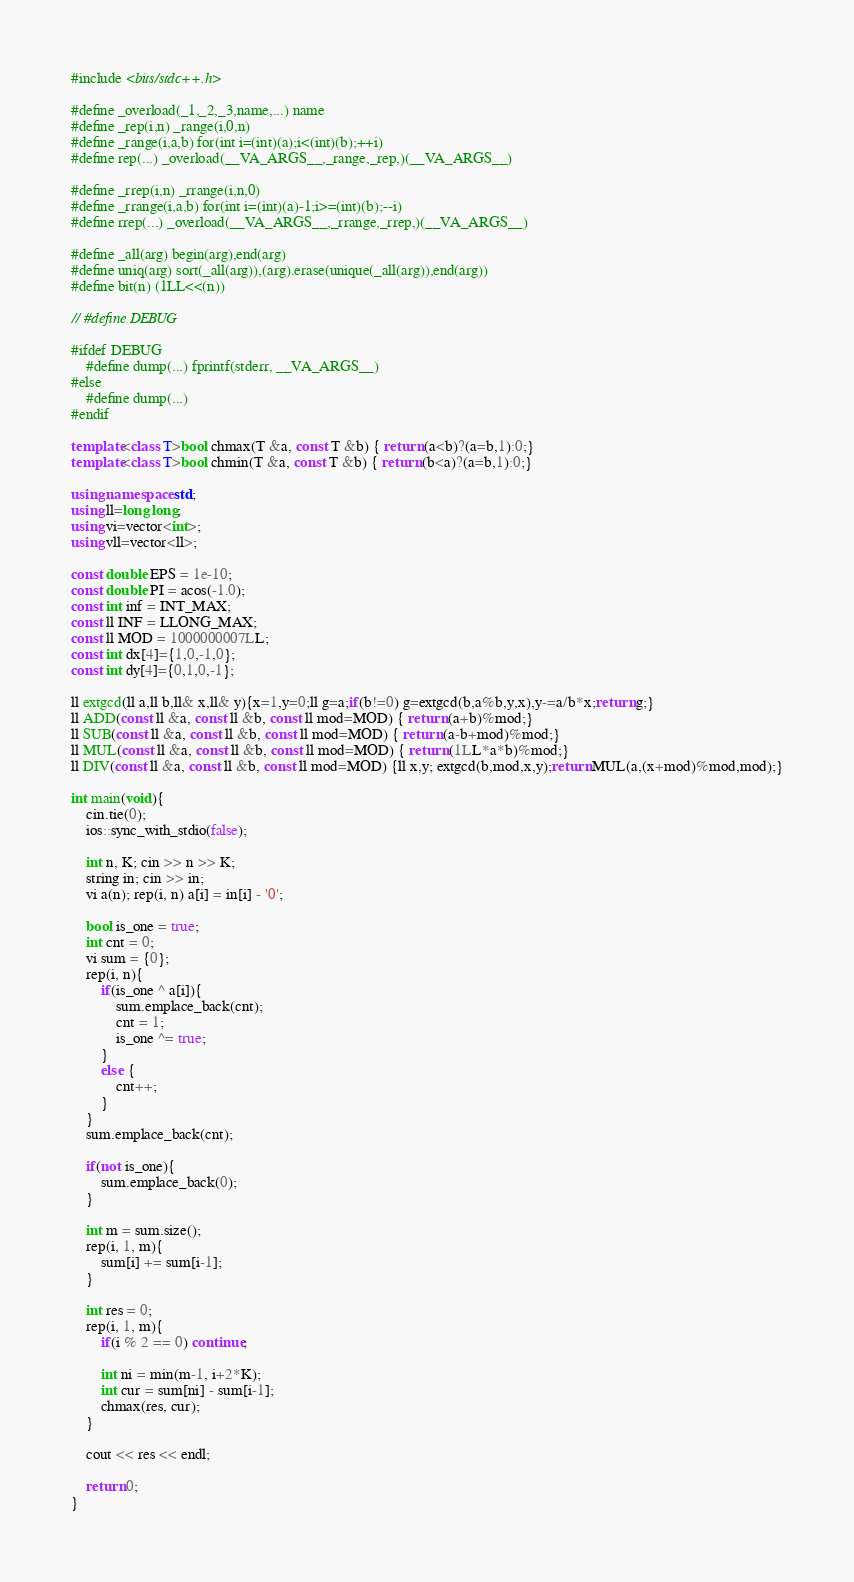<code> <loc_0><loc_0><loc_500><loc_500><_C++_>#include <bits/stdc++.h>
 
#define _overload(_1,_2,_3,name,...) name
#define _rep(i,n) _range(i,0,n)
#define _range(i,a,b) for(int i=(int)(a);i<(int)(b);++i)
#define rep(...) _overload(__VA_ARGS__,_range,_rep,)(__VA_ARGS__)
 
#define _rrep(i,n) _rrange(i,n,0)
#define _rrange(i,a,b) for(int i=(int)(a)-1;i>=(int)(b);--i)
#define rrep(...) _overload(__VA_ARGS__,_rrange,_rrep,)(__VA_ARGS__)
 
#define _all(arg) begin(arg),end(arg)
#define uniq(arg) sort(_all(arg)),(arg).erase(unique(_all(arg)),end(arg))
#define bit(n) (1LL<<(n))
 
// #define DEBUG
 
#ifdef DEBUG
    #define dump(...) fprintf(stderr, __VA_ARGS__)
#else
    #define dump(...)
#endif
 
template<class T>bool chmax(T &a, const T &b) { return (a<b)?(a=b,1):0;}
template<class T>bool chmin(T &a, const T &b) { return (b<a)?(a=b,1):0;}
 
using namespace std;
using ll=long long;
using vi=vector<int>;
using vll=vector<ll>;
 
const double EPS = 1e-10;
const double PI = acos(-1.0);
const int inf = INT_MAX;
const ll INF = LLONG_MAX;
const ll MOD = 1000000007LL;
const int dx[4]={1,0,-1,0};
const int dy[4]={0,1,0,-1};
 
ll extgcd(ll a,ll b,ll& x,ll& y){x=1,y=0;ll g=a;if(b!=0) g=extgcd(b,a%b,y,x),y-=a/b*x;return g;}
ll ADD(const ll &a, const ll &b, const ll mod=MOD) { return (a+b)%mod;}
ll SUB(const ll &a, const ll &b, const ll mod=MOD) { return (a-b+mod)%mod;}
ll MUL(const ll &a, const ll &b, const ll mod=MOD) { return (1LL*a*b)%mod;}
ll DIV(const ll &a, const ll &b, const ll mod=MOD) {ll x,y; extgcd(b,mod,x,y);return MUL(a,(x+mod)%mod,mod);}
 
int main(void){
    cin.tie(0);
    ios::sync_with_stdio(false);

    int n, K; cin >> n >> K;
    string in; cin >> in;
    vi a(n); rep(i, n) a[i] = in[i] - '0';

    bool is_one = true;
    int cnt = 0;
    vi sum = {0};
    rep(i, n){
        if(is_one ^ a[i]){
            sum.emplace_back(cnt);
            cnt = 1;
            is_one ^= true;
        }
        else {
            cnt++;
        }
    }
    sum.emplace_back(cnt);

    if(not is_one){
        sum.emplace_back(0);
    }

    int m = sum.size();
    rep(i, 1, m){
        sum[i] += sum[i-1];
    }

    int res = 0;
    rep(i, 1, m){
        if(i % 2 == 0) continue;

        int ni = min(m-1, i+2*K);
        int cur = sum[ni] - sum[i-1];
        chmax(res, cur);
    }
    
    cout << res << endl;

    return 0;
}
</code> 